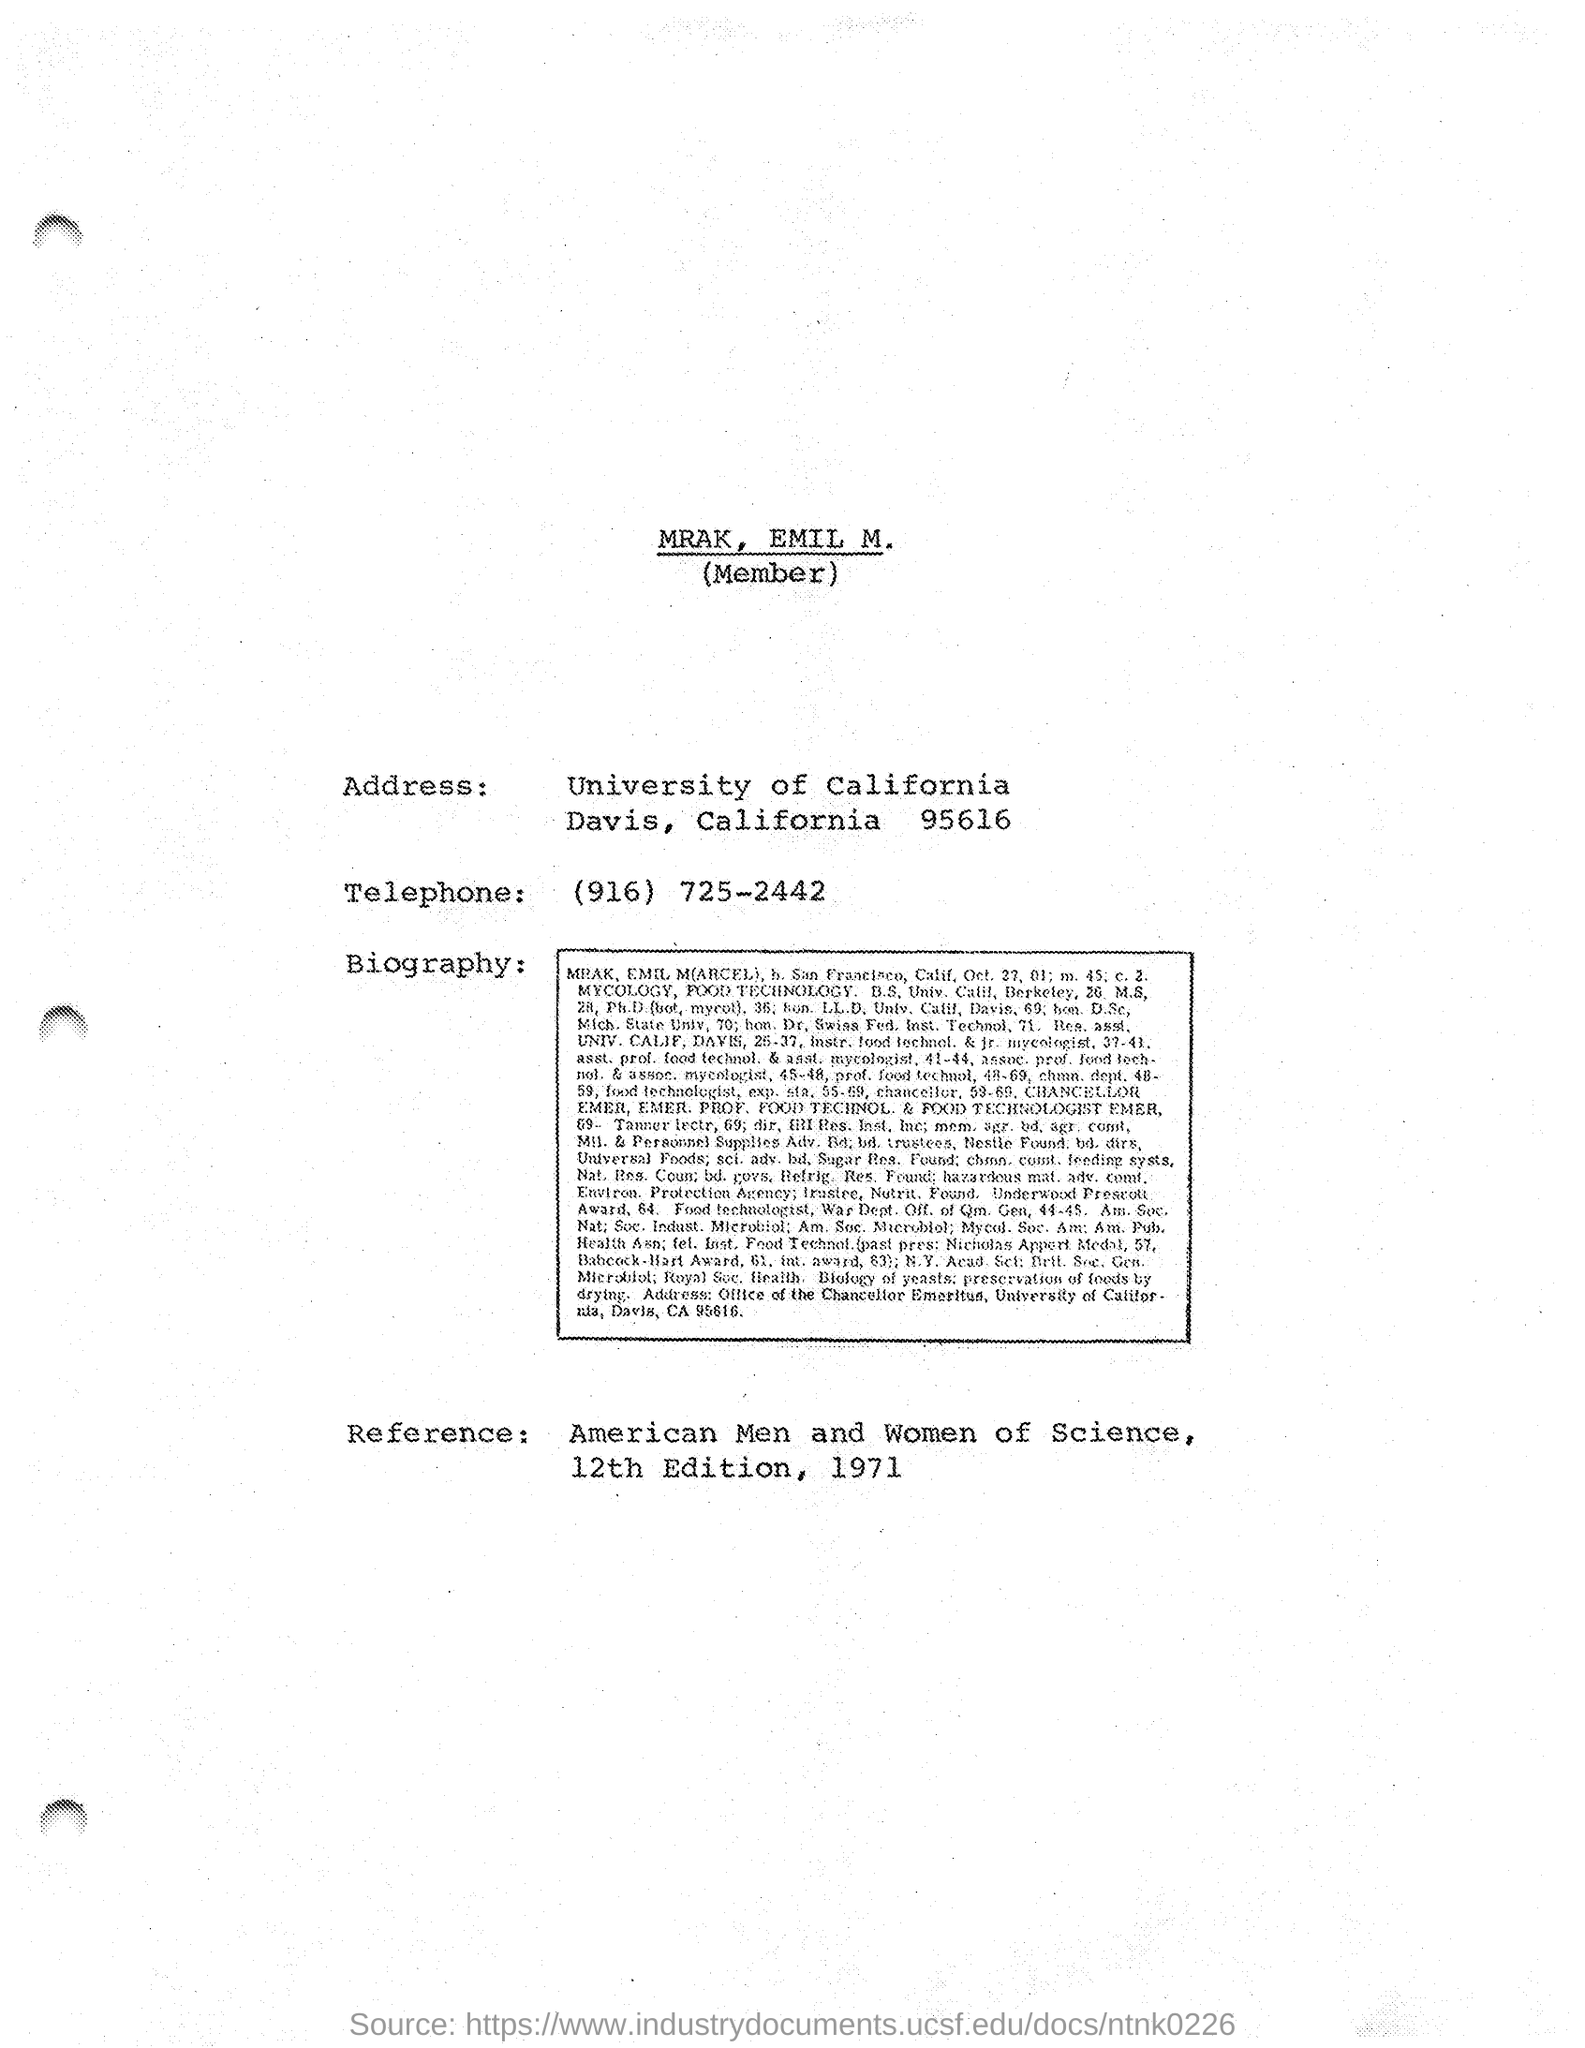Highlight a few significant elements in this photo. The edition number mentioned in the reference is unclear. It is possibly the 12th edition. The telephone number mentioned is (916) 725-2442. The name of the university is the University of California. 